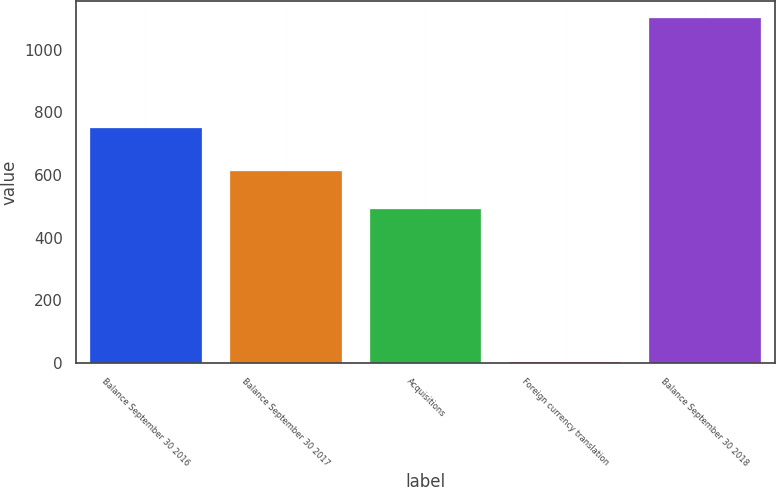<chart> <loc_0><loc_0><loc_500><loc_500><bar_chart><fcel>Balance September 30 2016<fcel>Balance September 30 2017<fcel>Acquisitions<fcel>Foreign currency translation<fcel>Balance September 30 2018<nl><fcel>749<fcel>612<fcel>492<fcel>4<fcel>1100<nl></chart> 